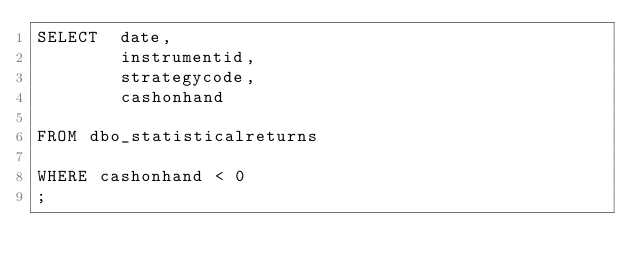<code> <loc_0><loc_0><loc_500><loc_500><_SQL_>SELECT  date,
        instrumentid,
        strategycode,
        cashonhand
       
FROM dbo_statisticalreturns

WHERE cashonhand < 0
;

</code> 